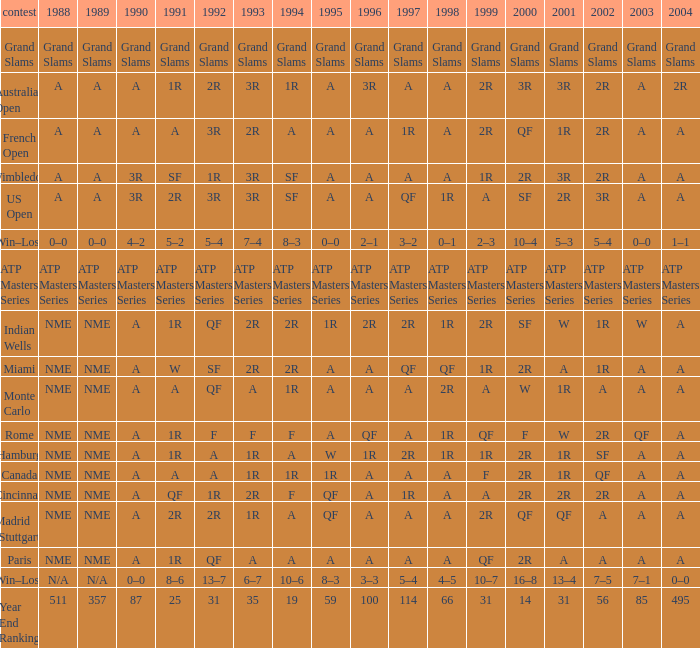What shows for 1992 when 1988 is A, at the Australian Open? 2R. 